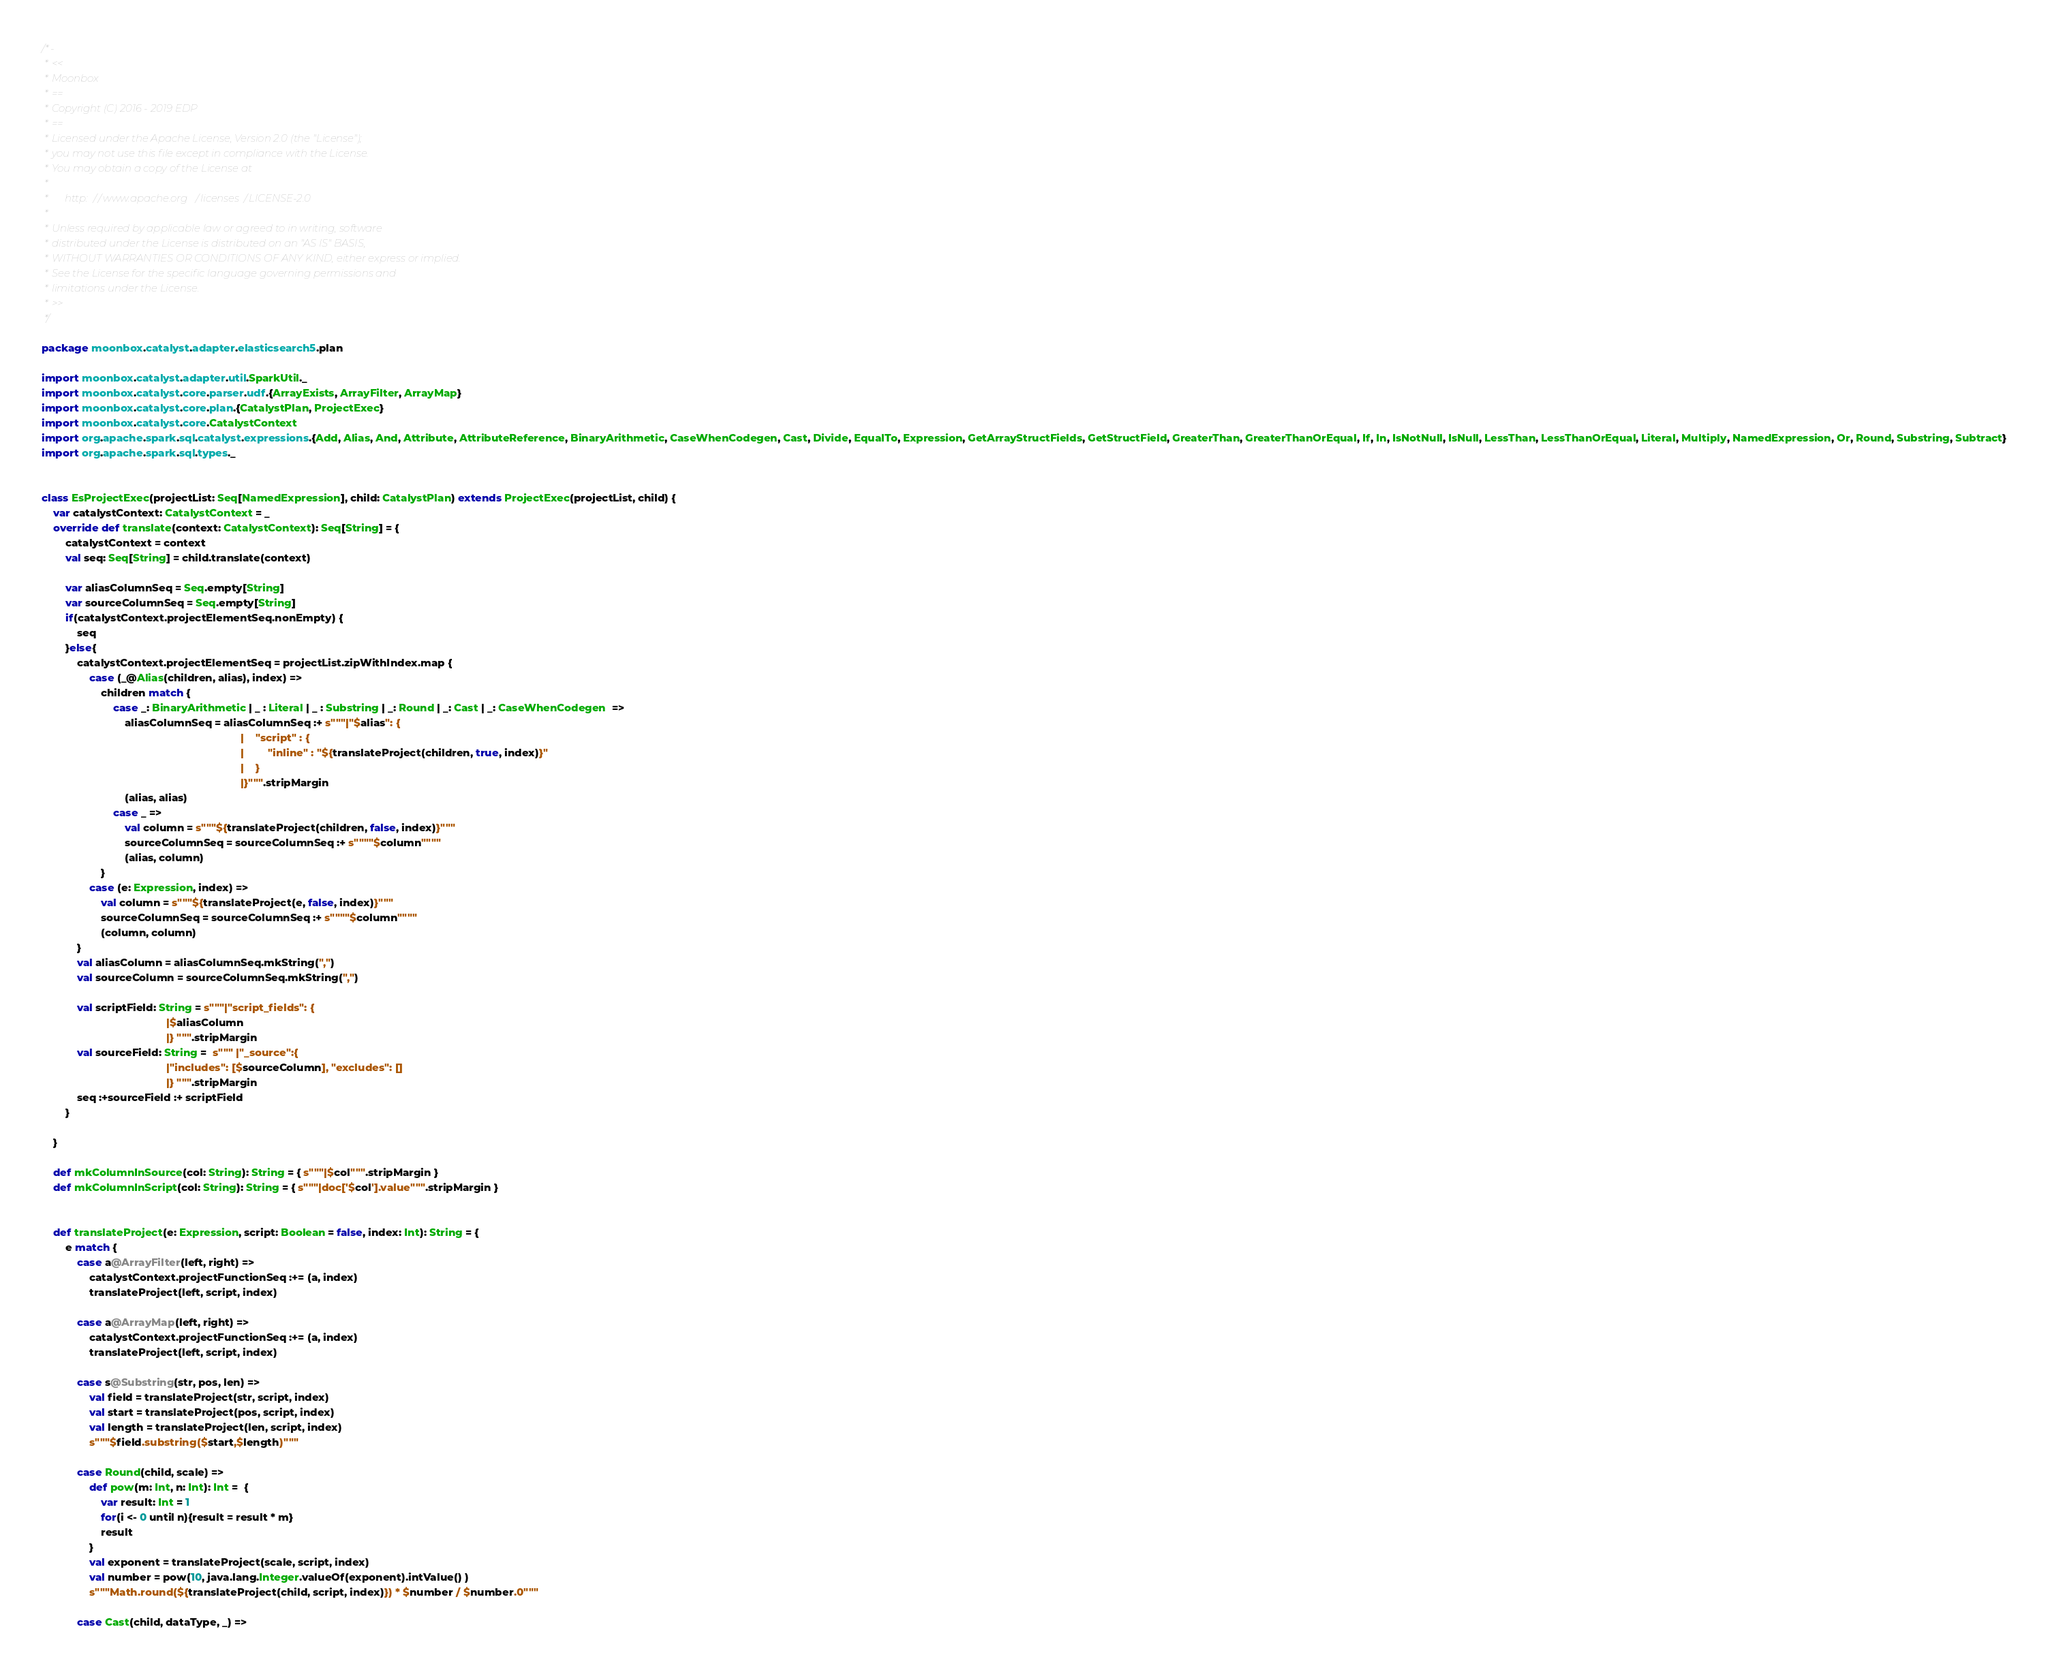Convert code to text. <code><loc_0><loc_0><loc_500><loc_500><_Scala_>/*-
 * <<
 * Moonbox
 * ==
 * Copyright (C) 2016 - 2019 EDP
 * ==
 * Licensed under the Apache License, Version 2.0 (the "License");
 * you may not use this file except in compliance with the License.
 * You may obtain a copy of the License at
 * 
 *      http://www.apache.org/licenses/LICENSE-2.0
 * 
 * Unless required by applicable law or agreed to in writing, software
 * distributed under the License is distributed on an "AS IS" BASIS,
 * WITHOUT WARRANTIES OR CONDITIONS OF ANY KIND, either express or implied.
 * See the License for the specific language governing permissions and
 * limitations under the License.
 * >>
 */

package moonbox.catalyst.adapter.elasticsearch5.plan

import moonbox.catalyst.adapter.util.SparkUtil._
import moonbox.catalyst.core.parser.udf.{ArrayExists, ArrayFilter, ArrayMap}
import moonbox.catalyst.core.plan.{CatalystPlan, ProjectExec}
import moonbox.catalyst.core.CatalystContext
import org.apache.spark.sql.catalyst.expressions.{Add, Alias, And, Attribute, AttributeReference, BinaryArithmetic, CaseWhenCodegen, Cast, Divide, EqualTo, Expression, GetArrayStructFields, GetStructField, GreaterThan, GreaterThanOrEqual, If, In, IsNotNull, IsNull, LessThan, LessThanOrEqual, Literal, Multiply, NamedExpression, Or, Round, Substring, Subtract}
import org.apache.spark.sql.types._


class EsProjectExec(projectList: Seq[NamedExpression], child: CatalystPlan) extends ProjectExec(projectList, child) {
    var catalystContext: CatalystContext = _
    override def translate(context: CatalystContext): Seq[String] = {
        catalystContext = context
        val seq: Seq[String] = child.translate(context)

        var aliasColumnSeq = Seq.empty[String]
        var sourceColumnSeq = Seq.empty[String]
        if(catalystContext.projectElementSeq.nonEmpty) {
            seq
        }else{
            catalystContext.projectElementSeq = projectList.zipWithIndex.map {
                case (_@Alias(children, alias), index) =>
                    children match {
                        case _: BinaryArithmetic | _ : Literal | _ : Substring | _: Round | _: Cast | _: CaseWhenCodegen  =>
                            aliasColumnSeq = aliasColumnSeq :+ s"""|"$alias": {
                                                                   |    "script" : {
                                                                   |        "inline" : "${translateProject(children, true, index)}"
                                                                   |    }
                                                                   |}""".stripMargin
                            (alias, alias)
                        case _ =>
                            val column = s"""${translateProject(children, false, index)}"""
                            sourceColumnSeq = sourceColumnSeq :+ s""""$column""""
                            (alias, column)
                    }
                case (e: Expression, index) =>
                    val column = s"""${translateProject(e, false, index)}"""
                    sourceColumnSeq = sourceColumnSeq :+ s""""$column""""
                    (column, column)
            }
            val aliasColumn = aliasColumnSeq.mkString(",")
            val sourceColumn = sourceColumnSeq.mkString(",")

            val scriptField: String = s"""|"script_fields": {
                                          |$aliasColumn
                                          |} """.stripMargin
            val sourceField: String =  s""" |"_source":{
                                          |"includes": [$sourceColumn], "excludes": []
                                          |} """.stripMargin
            seq :+sourceField :+ scriptField
        }

    }

    def mkColumnInSource(col: String): String = { s"""|$col""".stripMargin }
    def mkColumnInScript(col: String): String = { s"""|doc['$col'].value""".stripMargin }


    def translateProject(e: Expression, script: Boolean = false, index: Int): String = {
        e match {
            case a@ArrayFilter(left, right) =>
                catalystContext.projectFunctionSeq :+= (a, index)
                translateProject(left, script, index)

            case a@ArrayMap(left, right) =>
                catalystContext.projectFunctionSeq :+= (a, index)
                translateProject(left, script, index)

            case s@Substring(str, pos, len) =>
                val field = translateProject(str, script, index)
                val start = translateProject(pos, script, index)
                val length = translateProject(len, script, index)
                s"""$field.substring($start,$length)"""

            case Round(child, scale) =>
                def pow(m: Int, n: Int): Int =  {
                    var result: Int = 1
                    for(i <- 0 until n){result = result * m}
                    result
                }
                val exponent = translateProject(scale, script, index)
                val number = pow(10, java.lang.Integer.valueOf(exponent).intValue() )
                s"""Math.round(${translateProject(child, script, index)}) * $number / $number.0"""

            case Cast(child, dataType, _) =></code> 